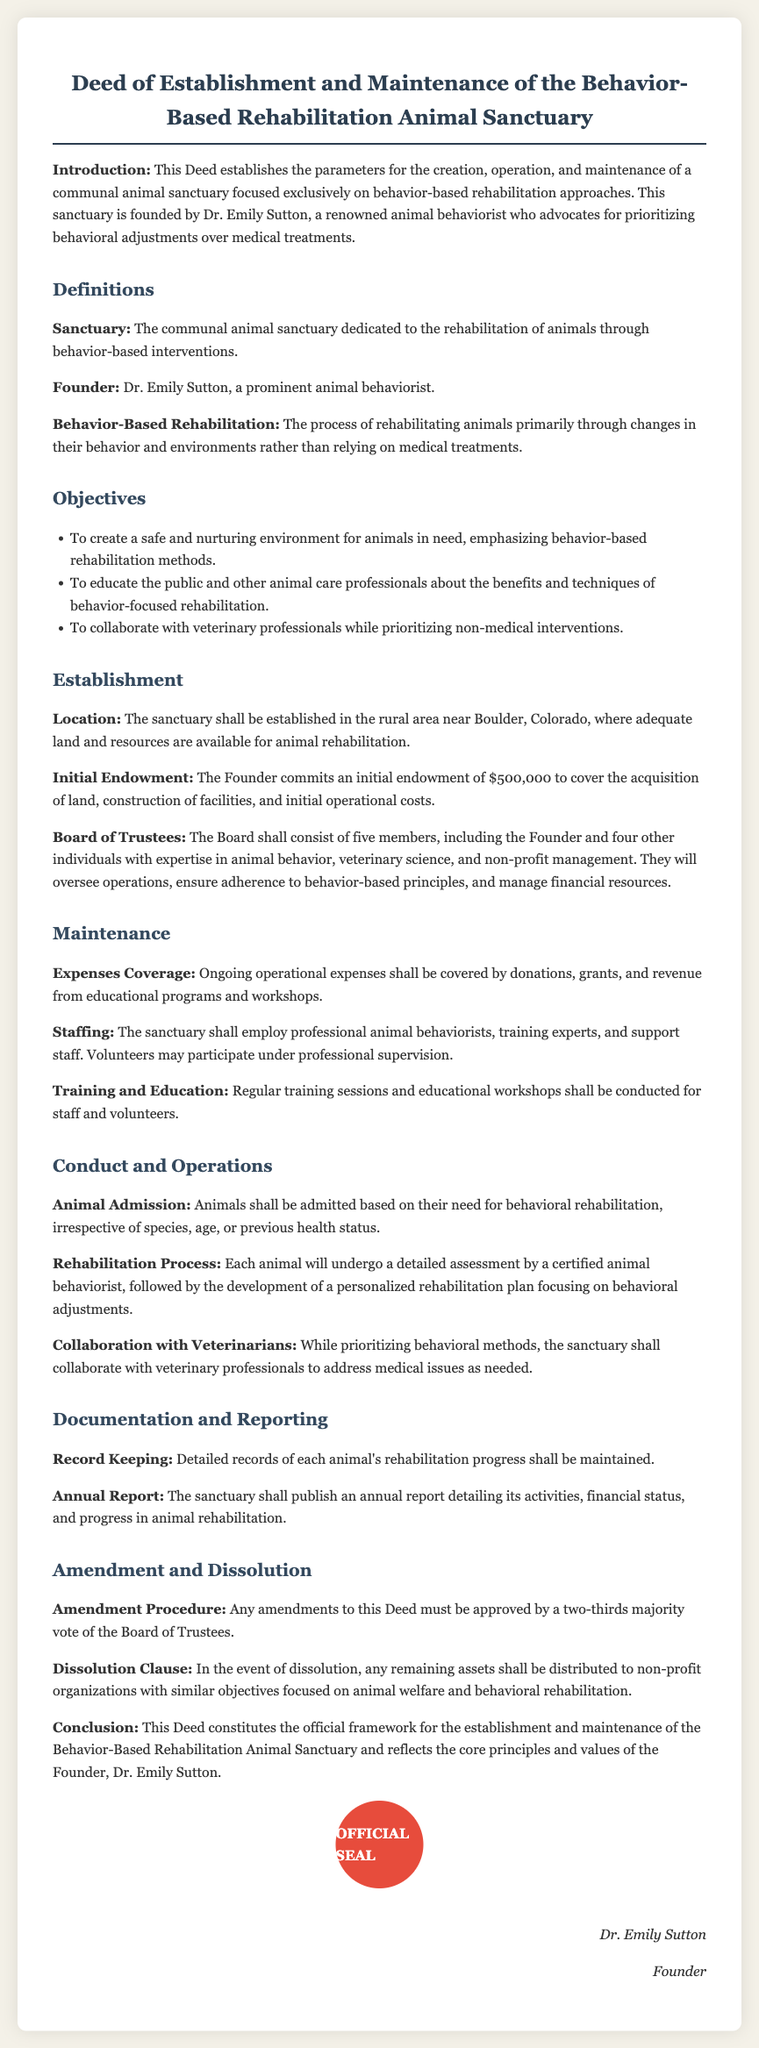What is the name of the founder? The document specifies the founder as Dr. Emily Sutton.
Answer: Dr. Emily Sutton What is the initial endowment amount? The initial endowment committed by the Founder to cover various costs is clearly stated as $500,000.
Answer: $500,000 Where is the sanctuary located? The document mentions that the sanctuary will be established in a rural area near Boulder, Colorado.
Answer: Boulder, Colorado What is one of the sanctuary's main objectives? One objective outlined is to create a safe and nurturing environment for animals emphasizing behavior-based rehabilitation methods.
Answer: Safe and nurturing environment How many members are on the Board of Trustees? The document states that the Board shall consist of five members.
Answer: Five What type of professionals will the sanctuary collaborate with? Collaboration will primarily be with veterinary professionals, as stated in the document.
Answer: Veterinary professionals What needs to happen for amendments to be made to the Deed? Amendments must be approved by a two-thirds majority vote of the Board of Trustees according to the document.
Answer: Two-thirds majority vote What will happen to assets if the sanctuary is dissolved? Any remaining assets will be distributed to non-profit organizations with similar objectives focused on animal welfare.
Answer: Non-profit organizations What is the process described for animal admission? Animals shall be admitted based on their need for behavioral rehabilitation irrespective of other factors.
Answer: Need for behavioral rehabilitation 